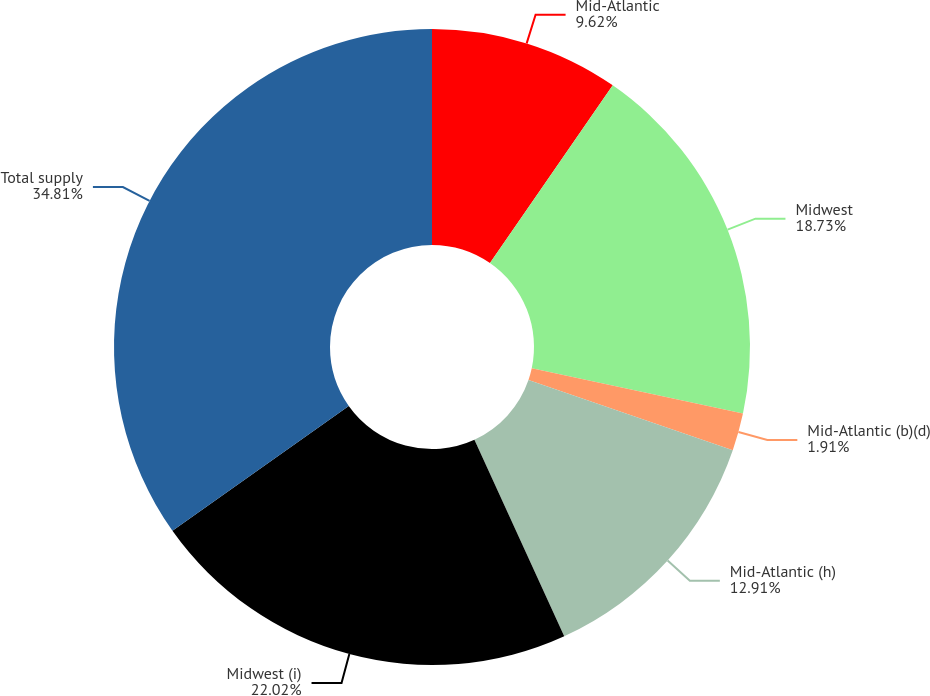Convert chart to OTSL. <chart><loc_0><loc_0><loc_500><loc_500><pie_chart><fcel>Mid-Atlantic<fcel>Midwest<fcel>Mid-Atlantic (b)(d)<fcel>Mid-Atlantic (h)<fcel>Midwest (i)<fcel>Total supply<nl><fcel>9.62%<fcel>18.73%<fcel>1.91%<fcel>12.91%<fcel>22.02%<fcel>34.8%<nl></chart> 